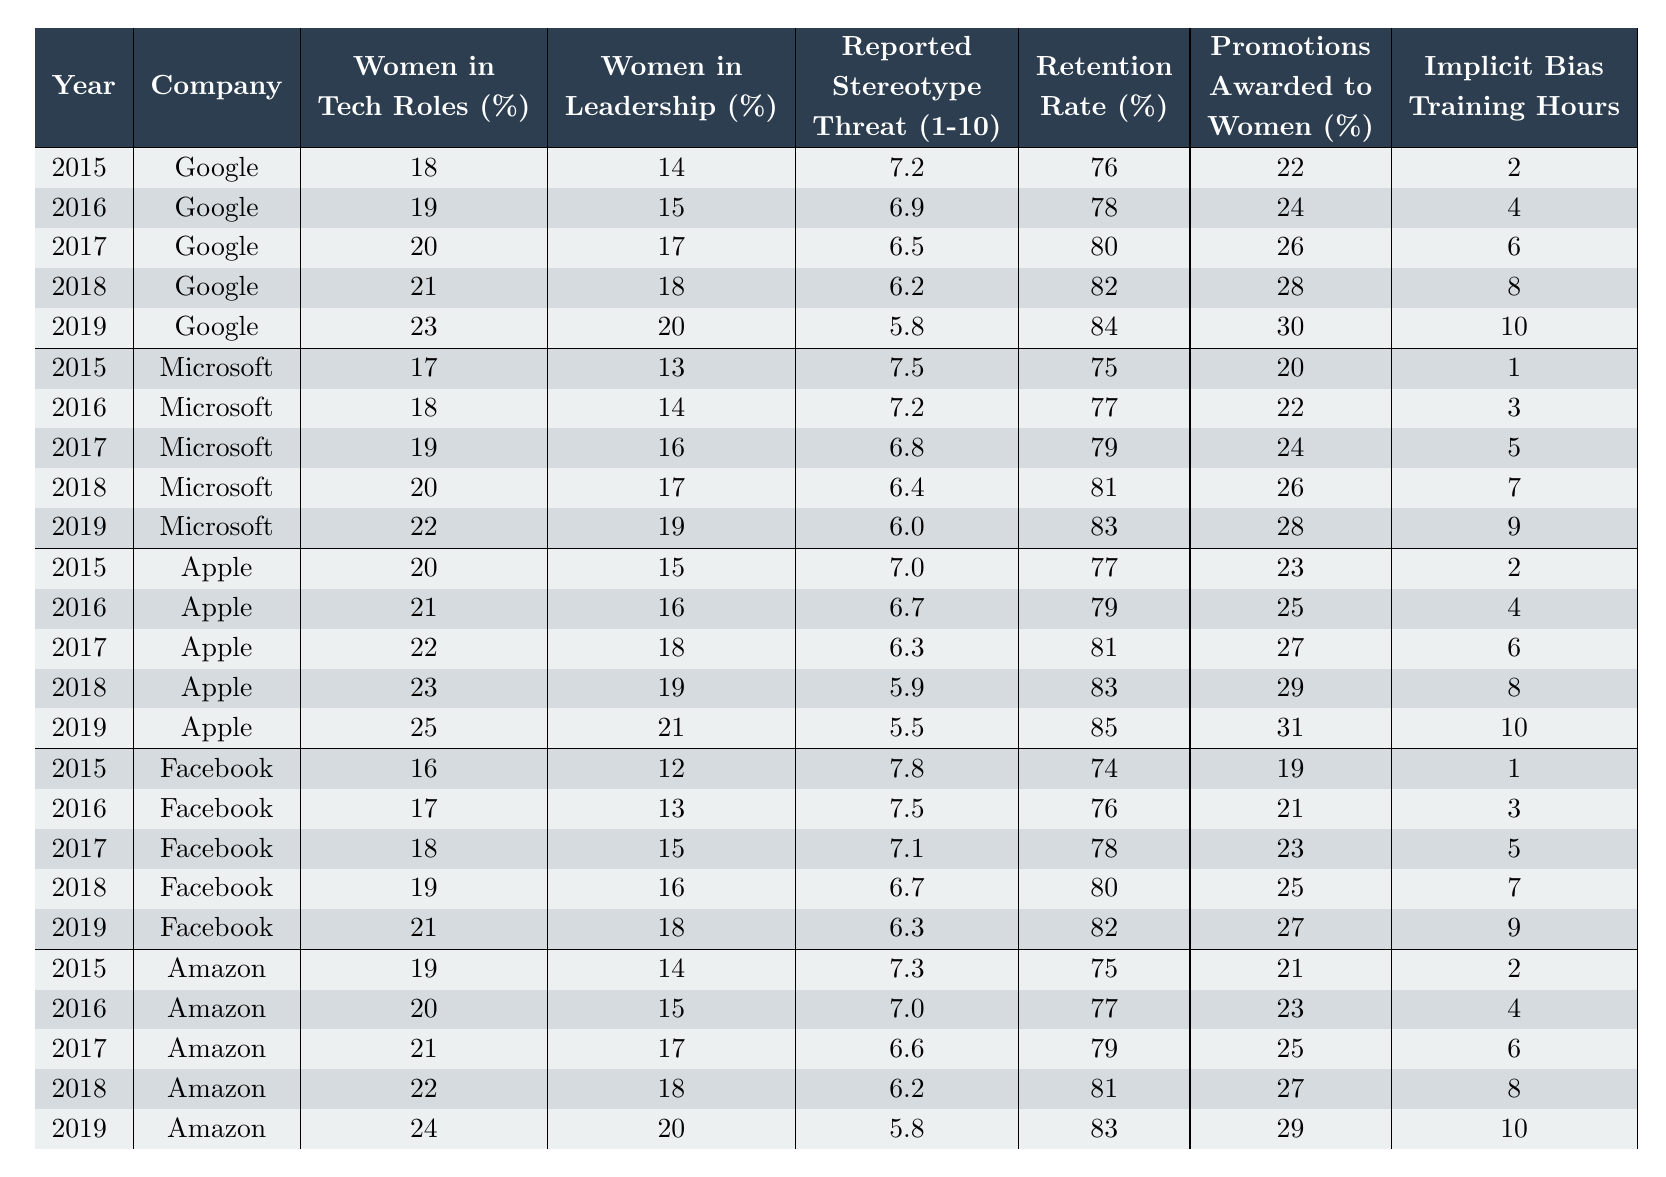What percentage of women in leadership roles did Google reach in 2019? Referring to the table, the value for Google in 2019 under "Women in Leadership (%)" is 20.
Answer: 20% What was the retention rate for Apple in 2018? The table shows that Apple had a retention rate of 83% in 2018.
Answer: 83% Which company reported the highest percentage of women in tech roles in 2019? The highest percentage of women in tech roles reported in 2019 was 25%, by Apple.
Answer: Apple What is the average reported stereotype threat for Microsoft from 2015 to 2019? The reported values for Microsoft are: 7.5, 7.2, 6.8, 6.4, and 6.0. The sum is 35.9 and the average is 35.9/5 = 7.18.
Answer: 7.18 Was there an increase in promotions awarded to women in Amazon from 2015 to 2019? The value for promotions awarded to women in Amazon increased from 21% in 2015 to 29% in 2019, indicating an increase.
Answer: Yes What was the overall trend in implicit bias training hours across all companies from 2015 to 2019? The total hours for each year can be summed: 2+1+2+1 = 6 (2015), 4+3+4+3 = 14 (2016), 6+5+6+5 = 22 (2017), 8+7+8+7 = 30 (2018), 10+9+10+9 = 38 (2019). Each year shows a consistent increase in training hours.
Answer: Increasing What was the difference in women in tech roles percentage between Facebook and Google in 2017? In 2017, Facebook had 18% and Google had 20% in tech roles. The difference is 20 - 18 = 2%.
Answer: 2% Which company had the lowest retention rate in 2015? Looking at the retention rates for 2015: Google (76), Microsoft (75), Apple (77), Facebook (74), Amazon (75). The lowest is 74% by Facebook.
Answer: Facebook How did the reported stereotype threat change for Apple from 2015 to 2019? Apple's reported stereotype threat decreased from 7.0 in 2015 to 5.5 in 2019, indicating a reduction.
Answer: Decreased How many promotions were awarded to women at Microsoft in 2019, and how does this compare to the 2015 value? Microsoft awarded 28% of promotions to women in 2019 compared to 20% in 2015. The increase is 28 - 20 = 8%.
Answer: 28% (8% increase) 